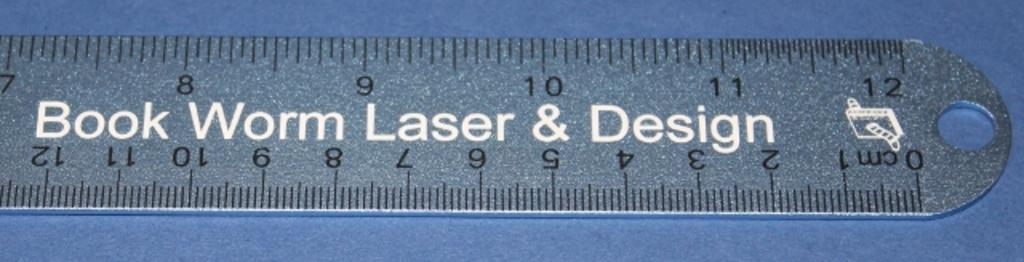<image>
Offer a succinct explanation of the picture presented. The last few inches of a ruler bear the name Book Work Laser & Design. 